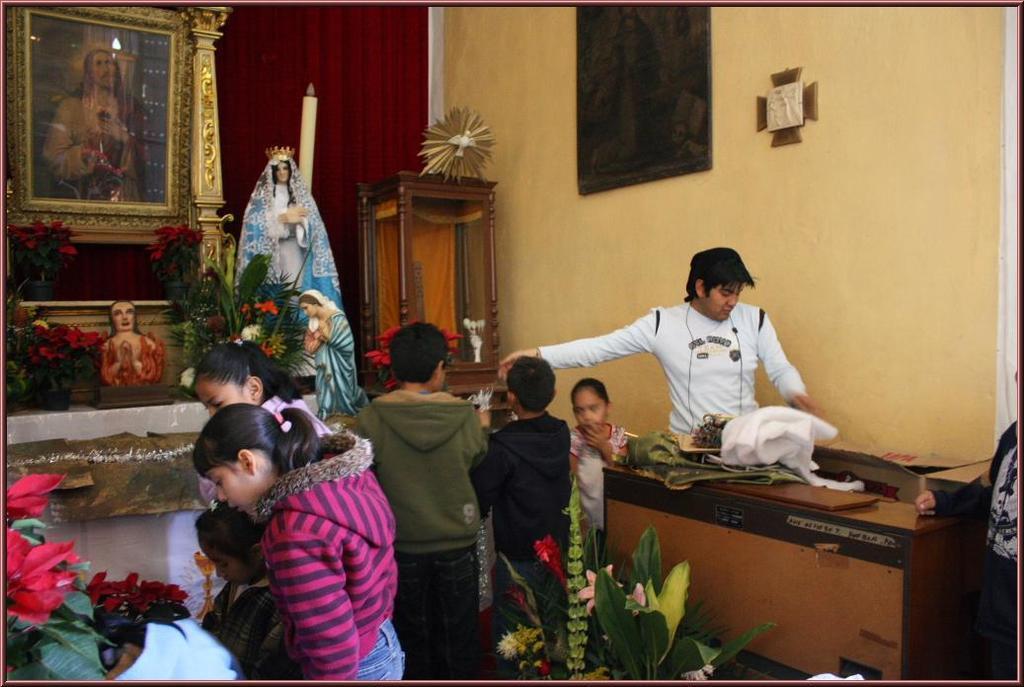Can you describe this image briefly? In this image there is a table with flower vases on it in, a wall with a frame in the left corner. There are people and flower vase in the foreground. There is a table with objects on it ,a person and wall in the left corner. There are people, wall with frames and objects in the background. 